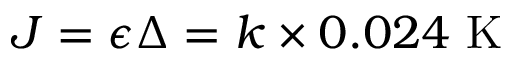<formula> <loc_0><loc_0><loc_500><loc_500>J = \epsilon \Delta = k \times 0 . 0 2 4 K</formula> 